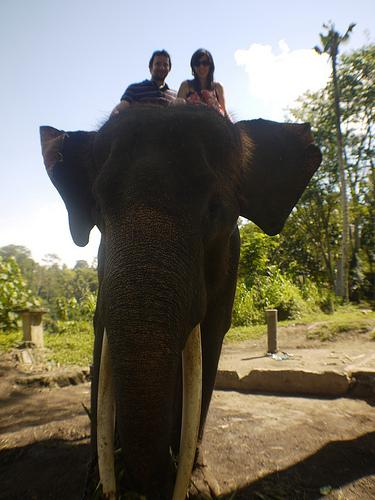Question: what type of animal is in the photo?
Choices:
A. A cow.
B. Polar bear.
C. Chickens.
D. Elephant.
Answer with the letter. Answer: D Question: how many elephants are there?
Choices:
A. Eating.
B. Sleeping.
C. One.
D. Walking.
Answer with the letter. Answer: C Question: what are the white things coming from the elephant's mouth?
Choices:
A. Tusks.
B. Teeth.
C. White carrots.
D. Saliva.
Answer with the letter. Answer: A Question: what is the elephant standing on?
Choices:
A. Box.
B. Ground.
C. Dirt.
D. Platform.
Answer with the letter. Answer: C Question: how many people are there?
Choices:
A. Man.
B. Lady.
C. Girl.
D. Two.
Answer with the letter. Answer: D 